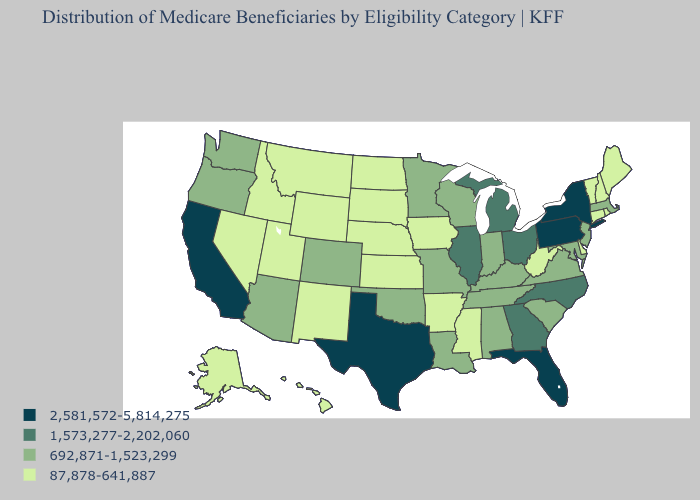What is the lowest value in states that border Arizona?
Concise answer only. 87,878-641,887. Does Rhode Island have the highest value in the Northeast?
Write a very short answer. No. Among the states that border South Dakota , which have the highest value?
Answer briefly. Minnesota. What is the highest value in states that border North Dakota?
Write a very short answer. 692,871-1,523,299. Name the states that have a value in the range 87,878-641,887?
Write a very short answer. Alaska, Arkansas, Connecticut, Delaware, Hawaii, Idaho, Iowa, Kansas, Maine, Mississippi, Montana, Nebraska, Nevada, New Hampshire, New Mexico, North Dakota, Rhode Island, South Dakota, Utah, Vermont, West Virginia, Wyoming. What is the lowest value in states that border Utah?
Write a very short answer. 87,878-641,887. Which states hav the highest value in the Northeast?
Be succinct. New York, Pennsylvania. Name the states that have a value in the range 2,581,572-5,814,275?
Answer briefly. California, Florida, New York, Pennsylvania, Texas. What is the value of Michigan?
Keep it brief. 1,573,277-2,202,060. What is the value of Connecticut?
Keep it brief. 87,878-641,887. Name the states that have a value in the range 1,573,277-2,202,060?
Quick response, please. Georgia, Illinois, Michigan, North Carolina, Ohio. What is the highest value in the USA?
Give a very brief answer. 2,581,572-5,814,275. Which states have the lowest value in the USA?
Keep it brief. Alaska, Arkansas, Connecticut, Delaware, Hawaii, Idaho, Iowa, Kansas, Maine, Mississippi, Montana, Nebraska, Nevada, New Hampshire, New Mexico, North Dakota, Rhode Island, South Dakota, Utah, Vermont, West Virginia, Wyoming. Name the states that have a value in the range 692,871-1,523,299?
Give a very brief answer. Alabama, Arizona, Colorado, Indiana, Kentucky, Louisiana, Maryland, Massachusetts, Minnesota, Missouri, New Jersey, Oklahoma, Oregon, South Carolina, Tennessee, Virginia, Washington, Wisconsin. How many symbols are there in the legend?
Write a very short answer. 4. 